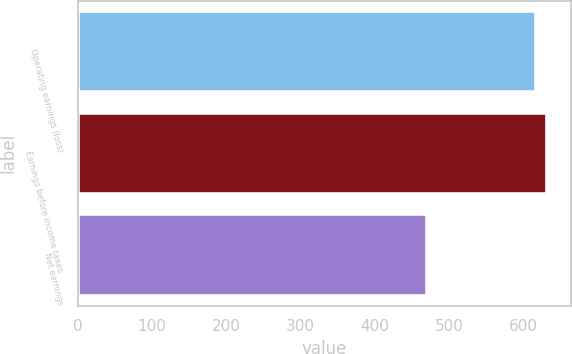<chart> <loc_0><loc_0><loc_500><loc_500><bar_chart><fcel>Operating earnings (loss)<fcel>Earnings before income taxes<fcel>Net earnings<nl><fcel>615.8<fcel>631.35<fcel>470.4<nl></chart> 